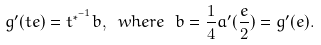<formula> <loc_0><loc_0><loc_500><loc_500>g ^ { \prime } ( t e ) = t ^ { { \ast } ^ { - 1 } } b , \ w h e r e \ b = \frac { 1 } { 4 } a ^ { \prime } ( \frac { e } { 2 } ) = g ^ { \prime } ( e ) .</formula> 